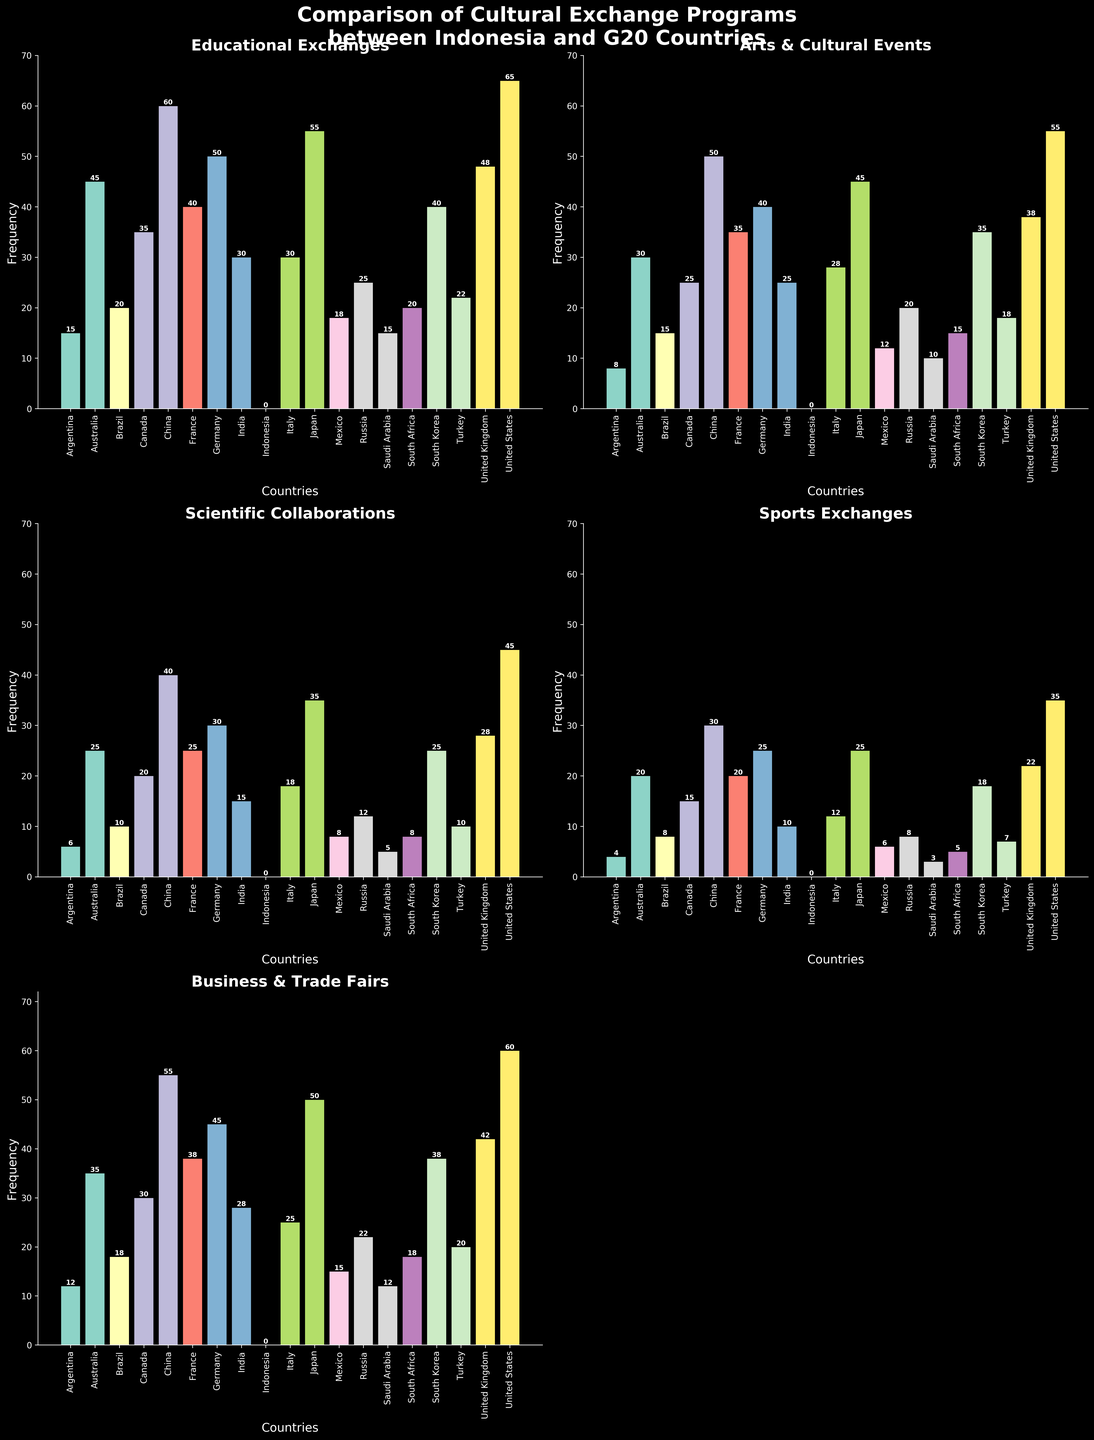Which country has the highest number of "Educational Exchanges" with Indonesia? By inspecting the bar heights under the "Educational Exchanges" subplot, we observe that the United States has the tallest bar indicating the highest frequency.
Answer: United States What is the difference in the number of "Scientific Collaborations" between Germany and Brazil? By referring to the "Scientific Collaborations" subplot, we see Germany has 30 and Brazil has 10. Therefore, the difference is 30 - 10 = 20.
Answer: 20 How many countries have more than 40 "Arts & Cultural Events" with Indonesia? In the "Arts & Cultural Events" subplot, visually count the countries with bars taller than 40, which are China, Japan, and the United States.
Answer: 3 What is the sum of "Sports Exchanges" conducted by Australia and Japan? From the "Sports Exchanges" subplot, Australia has 20 and Japan has 25. The sum is 20 + 25 = 45.
Answer: 45 Which type of cultural exchange program has the least overall frequency for Saudi Arabia? By comparing the bar heights across all subplots for Saudi Arabia, the "Sports Exchanges" has the shortest bar with a frequency of 3.
Answer: Sports Exchanges Is the number of "Business & Trade Fairs" higher for China or the United States? Inspecting the "Business & Trade Fairs" subplot, the United States has a higher bar than China (60 vs. 55).
Answer: United States What is the average number of "Educational Exchanges" across all G20 countries excluding Indonesia? Sum the "Educational Exchanges" values for all countries excluding Indonesia (15 + 45 + 20 + 35 + 60 + 40 + 50 + 30 + 30 + 55 + 18 + 25 + 15 + 20 + 40 + 22 + 48 + 65 = 633). Divide the sum by 18 (number of countries). So, 633 / 18 = 35.17.
Answer: 35.17 How does the frequency of "Arts & Cultural Events" in France compare to that in South Korea? Referring to the "Arts & Cultural Events" subplot, France has 35 while South Korea has 35 as well, so they are equal.
Answer: Equal Which country shows the highest frequency for "Scientific Collaborations" and what is the value? Observing the "Scientific Collaborations" subplot, the United States has the highest bar with a value of 45.
Answer: United States, 45 What is the combined frequency of "Business & Trade Fairs" events for Turkey and Italy? From the "Business & Trade Fairs" subplot, Turkey has 20 and Italy has 25. The combined total is 20 + 25 = 45.
Answer: 45 